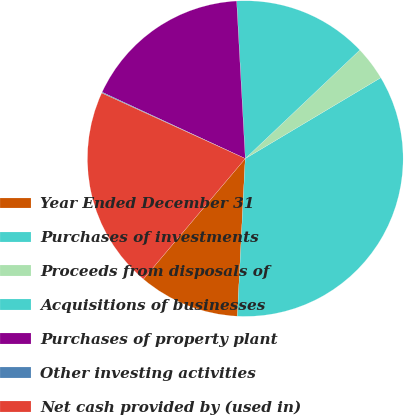<chart> <loc_0><loc_0><loc_500><loc_500><pie_chart><fcel>Year Ended December 31<fcel>Purchases of investments<fcel>Proceeds from disposals of<fcel>Acquisitions of businesses<fcel>Purchases of property plant<fcel>Other investing activities<fcel>Net cash provided by (used in)<nl><fcel>10.37%<fcel>34.36%<fcel>3.51%<fcel>13.8%<fcel>17.22%<fcel>0.09%<fcel>20.65%<nl></chart> 